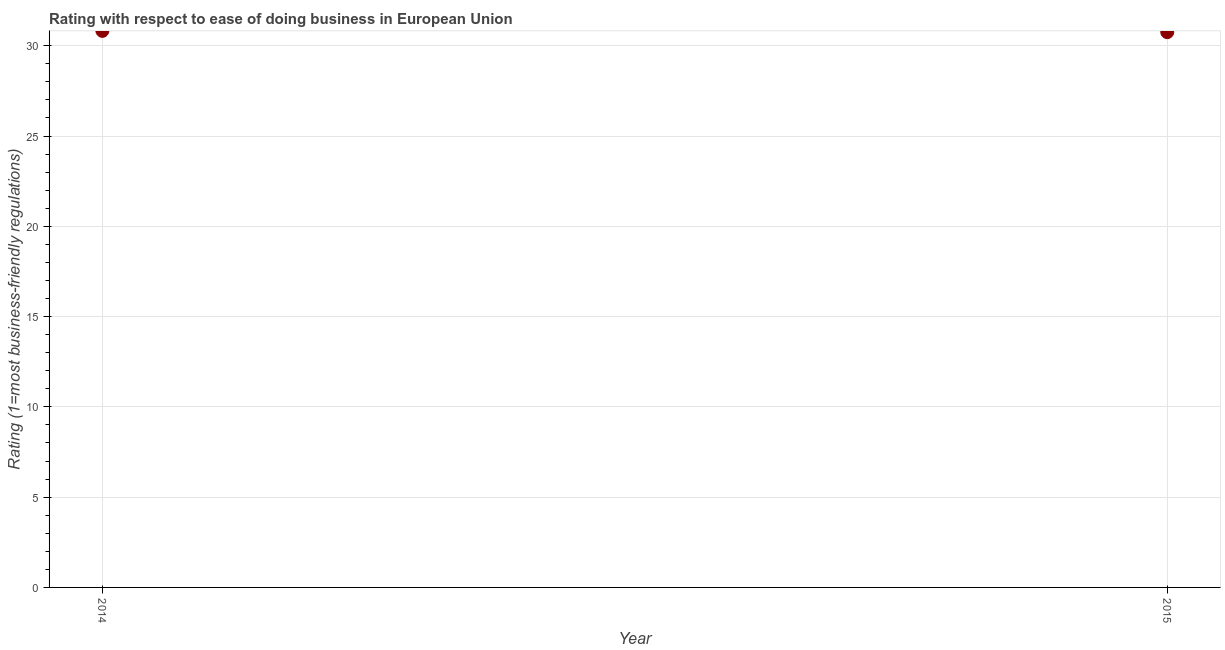What is the ease of doing business index in 2014?
Offer a very short reply. 30.82. Across all years, what is the maximum ease of doing business index?
Your answer should be very brief. 30.82. Across all years, what is the minimum ease of doing business index?
Make the answer very short. 30.75. In which year was the ease of doing business index minimum?
Offer a terse response. 2015. What is the sum of the ease of doing business index?
Your answer should be compact. 61.57. What is the difference between the ease of doing business index in 2014 and 2015?
Provide a succinct answer. 0.07. What is the average ease of doing business index per year?
Ensure brevity in your answer.  30.79. What is the median ease of doing business index?
Give a very brief answer. 30.79. In how many years, is the ease of doing business index greater than 22 ?
Make the answer very short. 2. Do a majority of the years between 2015 and 2014 (inclusive) have ease of doing business index greater than 13 ?
Give a very brief answer. No. What is the ratio of the ease of doing business index in 2014 to that in 2015?
Provide a succinct answer. 1. In how many years, is the ease of doing business index greater than the average ease of doing business index taken over all years?
Keep it short and to the point. 1. Does the ease of doing business index monotonically increase over the years?
Make the answer very short. No. How many dotlines are there?
Your answer should be compact. 1. Does the graph contain any zero values?
Keep it short and to the point. No. What is the title of the graph?
Offer a terse response. Rating with respect to ease of doing business in European Union. What is the label or title of the Y-axis?
Your answer should be compact. Rating (1=most business-friendly regulations). What is the Rating (1=most business-friendly regulations) in 2014?
Keep it short and to the point. 30.82. What is the Rating (1=most business-friendly regulations) in 2015?
Offer a terse response. 30.75. What is the difference between the Rating (1=most business-friendly regulations) in 2014 and 2015?
Provide a short and direct response. 0.07. 